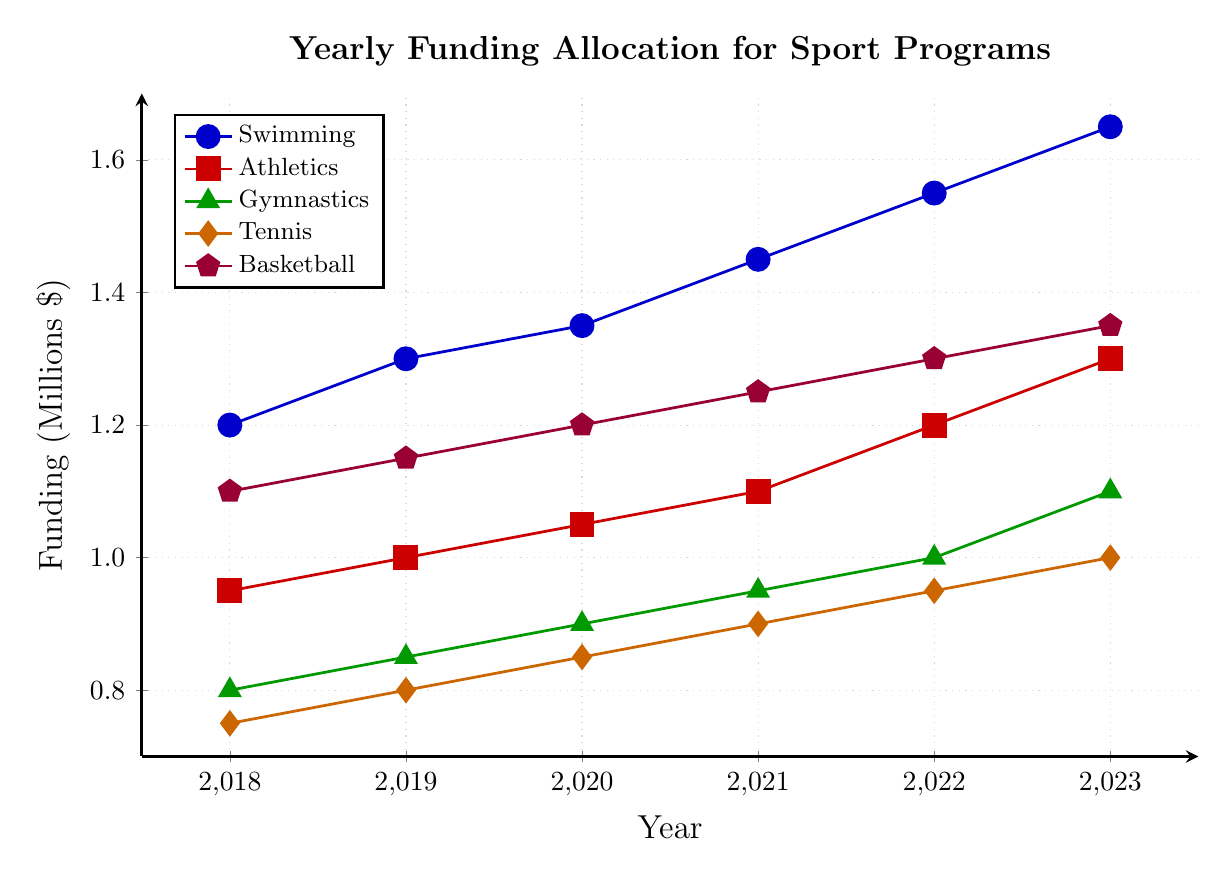Which sport program received the highest funding in 2023? By looking at the 2023 points on the graph for each sport program, the highest point corresponds to Swimming.
Answer: Swimming How much did the funding for Tennis increase from 2018 to 2023? In 2018, the funding for Tennis was $0.75 million, and in 2023, it was $1.0 million. The increase is $1.0 million - $0.75 million = $0.25 million.
Answer: $0.25 million Which two sport programs had the same funding increase between 2018 and 2023? By calculating the differences for each sport: Swimming ($1.65M - $1.2M = $0.45M), Athletics ($1.3M - $0.95M = $0.35M), Gymnastics ($1.1M - $0.8M = $0.3M), Tennis ($1.0M - $0.75M = $0.25M), Basketball ($1.35M - $1.1M = $0.25M). Tennis and Basketball had the same increase.
Answer: Tennis and Basketball What is the average funding for Gymnastics from 2018 to 2023? Sum the funding values for Gymnastics ($0.8M + $0.85M + $0.9M + $0.95M + $1.0M + $1.1M = $5.6M), then divide by the number of years (5.6/6 ≈ 0.933M).
Answer: $0.933 million Between 2020 and 2021, which sport program saw the largest absolute increase in funding? Calculate the increase for each sport between 2020 and 2021: Swimming ($1.45M - $1.35M = $0.1M), Athletics ($1.1M - $1.05M = $0.05M), Gymnastics ($0.95M - $0.9M = $0.05M), Tennis ($0.9M - $0.85M = $0.05M), Basketball ($1.25M - $1.2M = $0.05M). Swimming saw the largest increase of $0.1M.
Answer: Swimming How many sport programs had funding above $1 million in 2021? Observing the 2021 data points, Swimming ($1.45M), Athletics ($1.1M), Basketball ($1.25M), are above $1 million. Gymnastics and Tennis are below $1M.
Answer: 3 Which sport program showed the most consistent increase in funding over the years? All sport programs show a linear increase, but each sport’s line slopes upward at a consistent rate. However, inspecting closely, Athletics shows an incremental funding increase exactly by $0.05M every year, making it the most consistent.
Answer: Athletics By how much did the funding for Gymnastics increase from 2019 to 2023? In 2019, Gymnastics received $0.85 million, and in 2023 it received $1.1 million. The increase is $1.1 million - $0.85 million = $0.25 million.
Answer: $0.25 million 